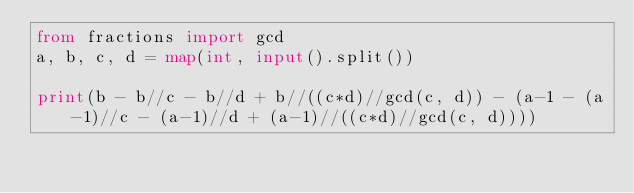<code> <loc_0><loc_0><loc_500><loc_500><_Python_>from fractions import gcd
a, b, c, d = map(int, input().split())

print(b - b//c - b//d + b//((c*d)//gcd(c, d)) - (a-1 - (a-1)//c - (a-1)//d + (a-1)//((c*d)//gcd(c, d))))</code> 